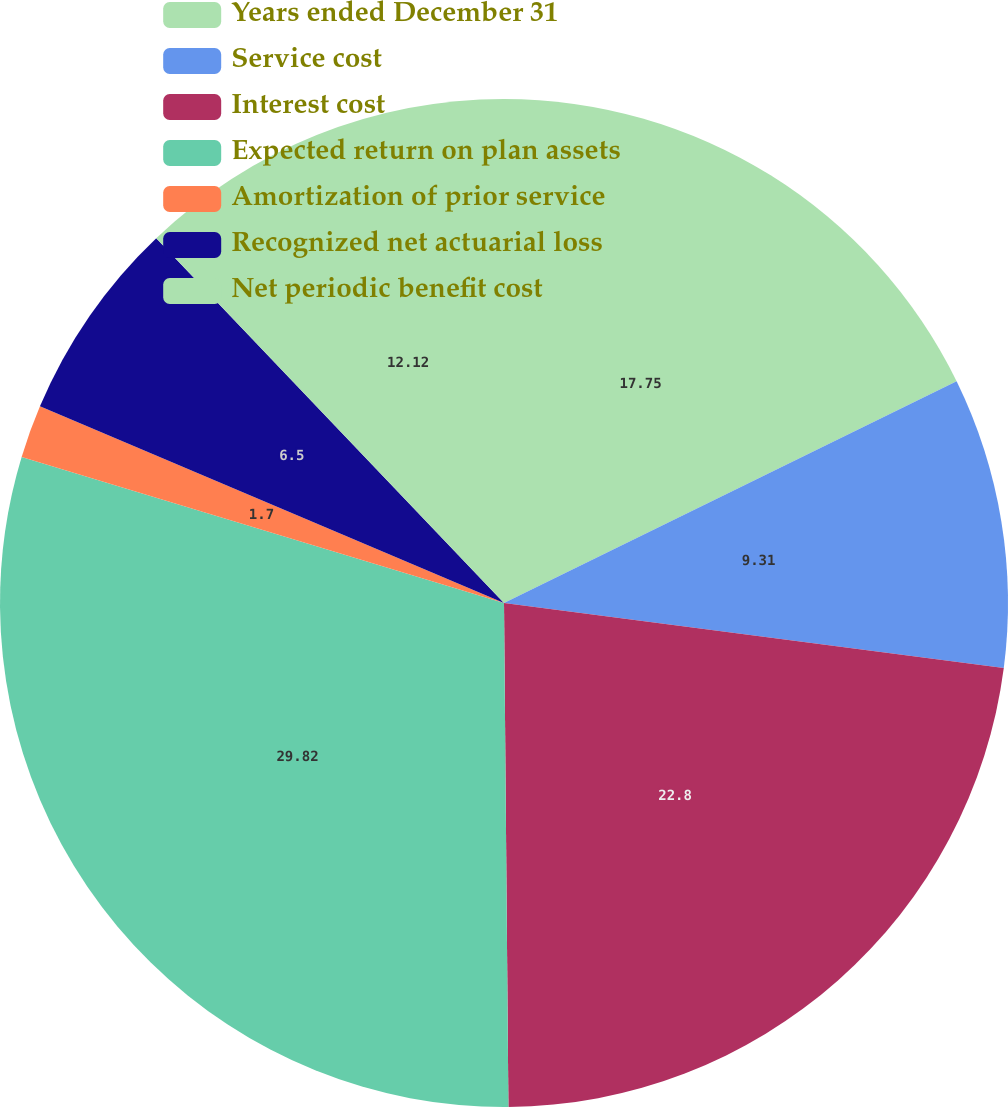Convert chart. <chart><loc_0><loc_0><loc_500><loc_500><pie_chart><fcel>Years ended December 31<fcel>Service cost<fcel>Interest cost<fcel>Expected return on plan assets<fcel>Amortization of prior service<fcel>Recognized net actuarial loss<fcel>Net periodic benefit cost<nl><fcel>17.75%<fcel>9.31%<fcel>22.8%<fcel>29.82%<fcel>1.7%<fcel>6.5%<fcel>12.12%<nl></chart> 